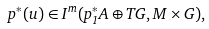Convert formula to latex. <formula><loc_0><loc_0><loc_500><loc_500>p ^ { * } ( u ) \in I ^ { m } ( p _ { 1 } ^ { * } A \oplus T G , M \times G ) ,</formula> 